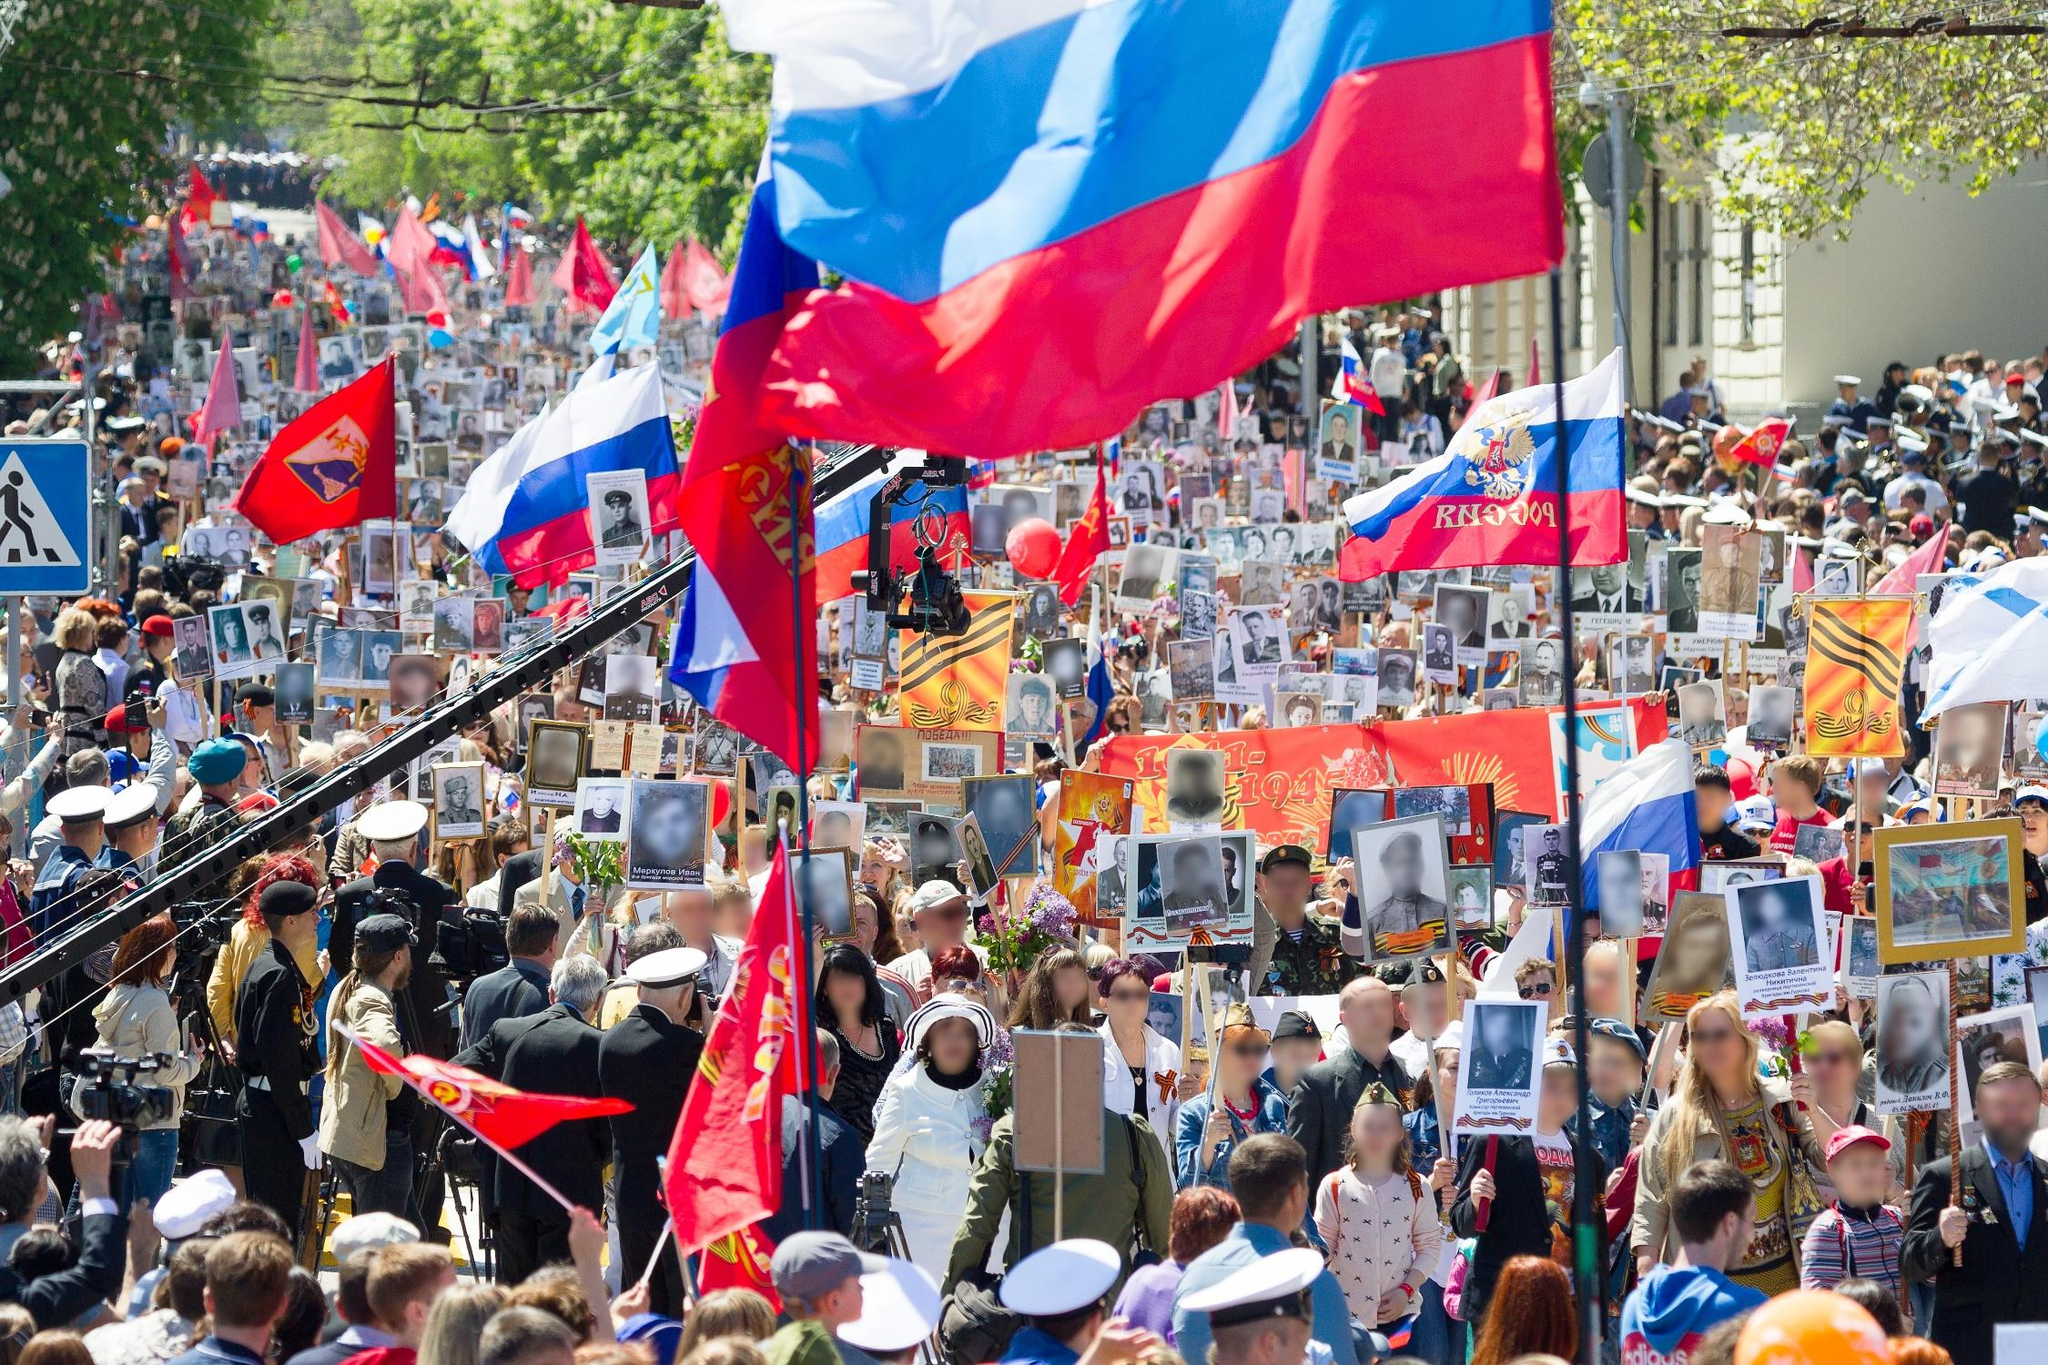Could you elaborate on the attire of the participants? How does it contribute to the event's atmosphere? The attire of the participants in the parade is quite diverse, reflecting a blend of contemporary and historical influences. Many individuals are dressed in formal or semi-formal clothing, some in military uniforms, while others wear casual attire. This mix of styles enhances the atmosphere of the event by showcasing respect and remembrance through more formal and traditional clothing, while the casual attire represents the involvement of everyday people. Military uniforms particularly stand out, symbolizing honor and valor, thus contributing significantly to the mood of reverence and solemnity. Imagine a detailed backstory for one of the photographs being held by a participant. One of the photographs being held by a participant features a young soldier in his early twenties, clad in a crisp military uniform. His name is Alexei, a brave and compassionate man who served during World War II. Born in a small village, he grew up with a deep sense of duty and patriotism inspired by his parents. During the war, Alexei became known not only for his courage in battle but also for his kindness. He would often share whatever little rations he had with his comrades and local families in need. Tragically, Alexei lost his life during a critical mission, but his legacy lived on through the stories shared by those who knew him. The photograph, lovingly preserved by his family, represents not only his heroic deeds but also the warmth and humanity he emanated. What kind of stories might the streets and buildings 'witness' during such a parade? The streets and buildings surrounding the parade would witness a tapestry of stories rich in history and emotion. Every footstep and cheer echo the memories of countless individuals whose lives have been shaped by the events being commemorated. The buildings, silent yet observant, have stood through triumphs and tragedies, acting as stoic guardians of the city's legacy. They've seen the formation of communities, the resilience of people during challenging times, and now, the collective act of remembrance. The streets have borne witness to the daily lives of countless citizens, and during the parade, they become a conduit for the collective consciousness of the community, resonating with pride, sorrow, and unity. 